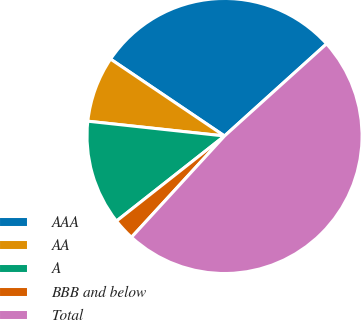<chart> <loc_0><loc_0><loc_500><loc_500><pie_chart><fcel>AAA<fcel>AA<fcel>A<fcel>BBB and below<fcel>Total<nl><fcel>28.86%<fcel>7.73%<fcel>12.33%<fcel>2.56%<fcel>48.51%<nl></chart> 